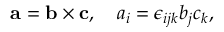<formula> <loc_0><loc_0><loc_500><loc_500>a = b \times c , \quad a _ { i } = \epsilon _ { i j k } b _ { j } c _ { k } , \,</formula> 